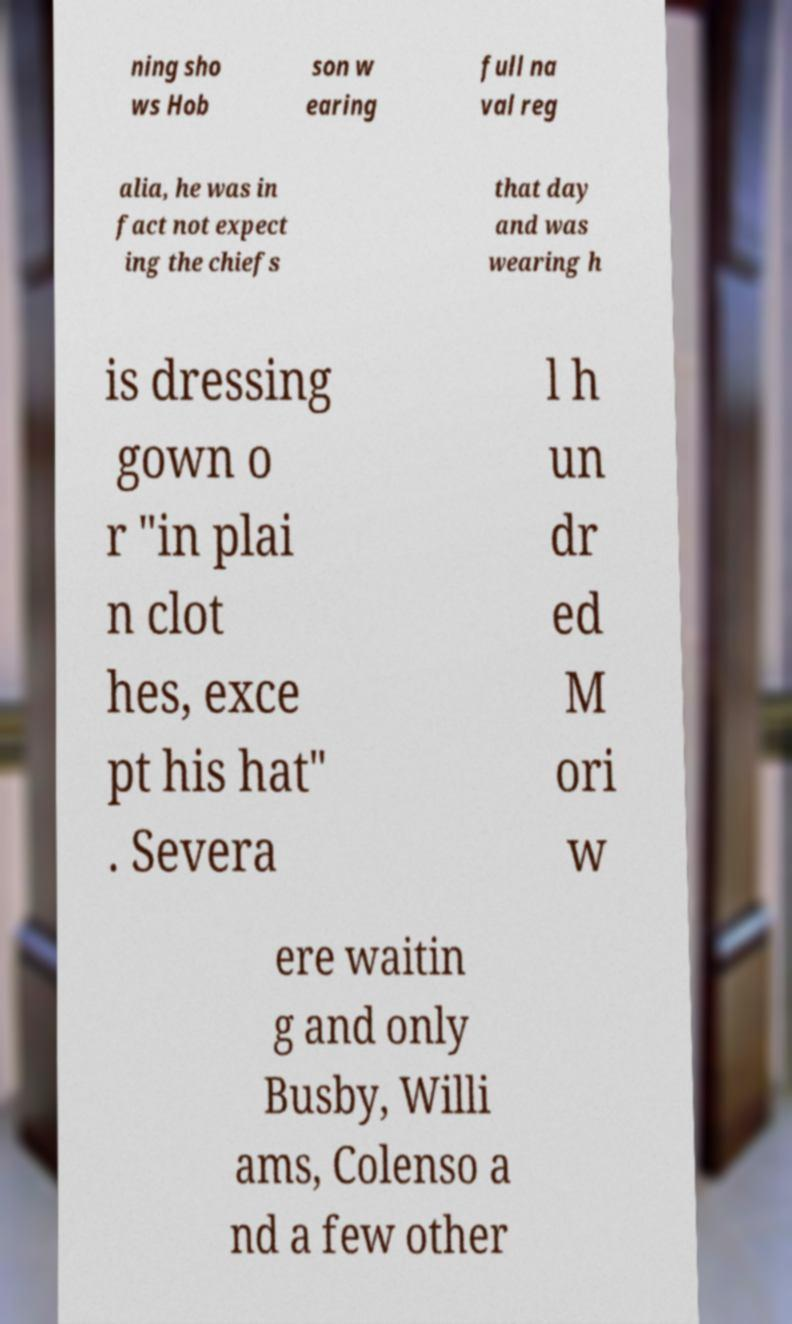For documentation purposes, I need the text within this image transcribed. Could you provide that? ning sho ws Hob son w earing full na val reg alia, he was in fact not expect ing the chiefs that day and was wearing h is dressing gown o r "in plai n clot hes, exce pt his hat" . Severa l h un dr ed M ori w ere waitin g and only Busby, Willi ams, Colenso a nd a few other 